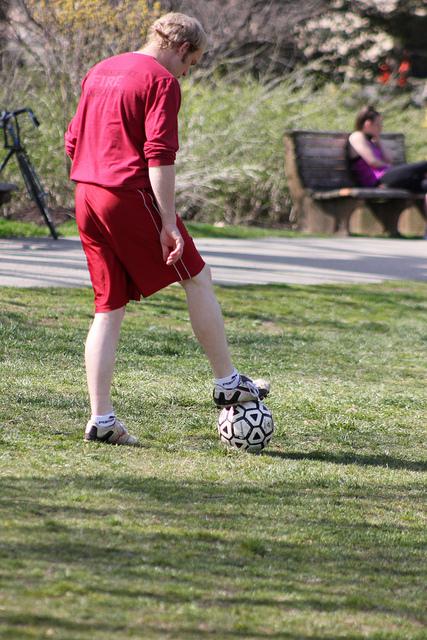Is it likely that this person spends more time than most people in the emergency room?
Keep it brief. No. What game is the man playing?
Be succinct. Soccer. Is this man happy?
Write a very short answer. No. How many people are sitting on the bench?
Give a very brief answer. 1. What sport is this?
Give a very brief answer. Soccer. What color are the man's shorts?
Write a very short answer. Red. Where is the ball?
Keep it brief. Grass. 